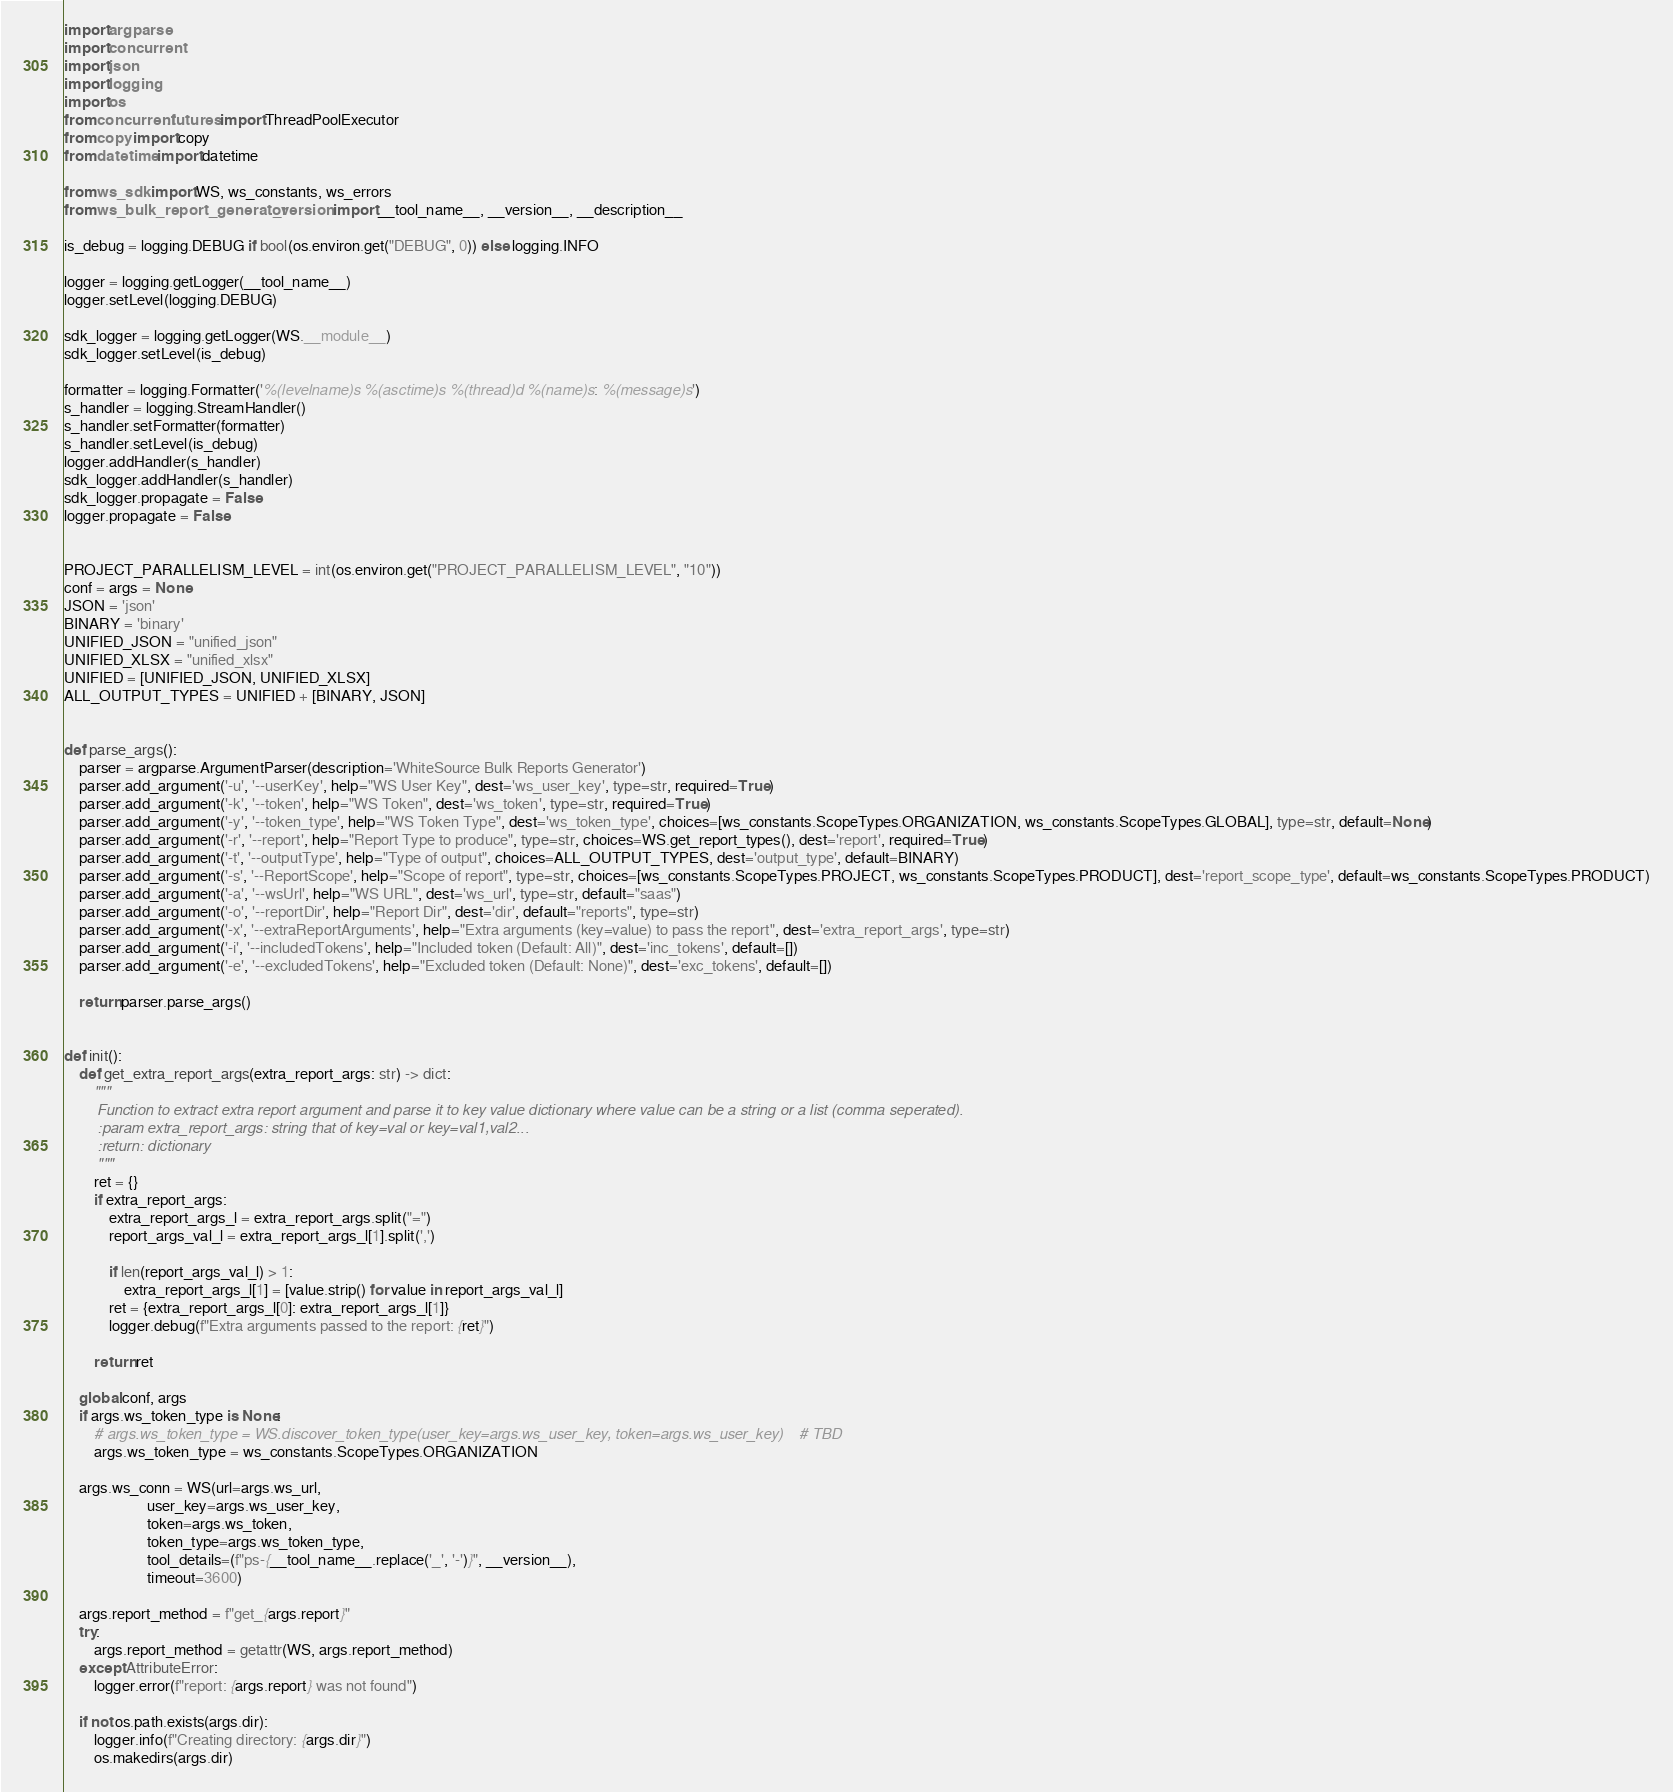Convert code to text. <code><loc_0><loc_0><loc_500><loc_500><_Python_>import argparse
import concurrent
import json
import logging
import os
from concurrent.futures import ThreadPoolExecutor
from copy import copy
from datetime import datetime

from ws_sdk import WS, ws_constants, ws_errors
from ws_bulk_report_generator._version import __tool_name__, __version__, __description__

is_debug = logging.DEBUG if bool(os.environ.get("DEBUG", 0)) else logging.INFO

logger = logging.getLogger(__tool_name__)
logger.setLevel(logging.DEBUG)

sdk_logger = logging.getLogger(WS.__module__)
sdk_logger.setLevel(is_debug)

formatter = logging.Formatter('%(levelname)s %(asctime)s %(thread)d %(name)s: %(message)s')
s_handler = logging.StreamHandler()
s_handler.setFormatter(formatter)
s_handler.setLevel(is_debug)
logger.addHandler(s_handler)
sdk_logger.addHandler(s_handler)
sdk_logger.propagate = False
logger.propagate = False


PROJECT_PARALLELISM_LEVEL = int(os.environ.get("PROJECT_PARALLELISM_LEVEL", "10"))
conf = args = None
JSON = 'json'
BINARY = 'binary'
UNIFIED_JSON = "unified_json"
UNIFIED_XLSX = "unified_xlsx"
UNIFIED = [UNIFIED_JSON, UNIFIED_XLSX]
ALL_OUTPUT_TYPES = UNIFIED + [BINARY, JSON]


def parse_args():
    parser = argparse.ArgumentParser(description='WhiteSource Bulk Reports Generator')
    parser.add_argument('-u', '--userKey', help="WS User Key", dest='ws_user_key', type=str, required=True)
    parser.add_argument('-k', '--token', help="WS Token", dest='ws_token', type=str, required=True)
    parser.add_argument('-y', '--token_type', help="WS Token Type", dest='ws_token_type', choices=[ws_constants.ScopeTypes.ORGANIZATION, ws_constants.ScopeTypes.GLOBAL], type=str, default=None)
    parser.add_argument('-r', '--report', help="Report Type to produce", type=str, choices=WS.get_report_types(), dest='report', required=True)
    parser.add_argument('-t', '--outputType', help="Type of output", choices=ALL_OUTPUT_TYPES, dest='output_type', default=BINARY)
    parser.add_argument('-s', '--ReportScope', help="Scope of report", type=str, choices=[ws_constants.ScopeTypes.PROJECT, ws_constants.ScopeTypes.PRODUCT], dest='report_scope_type', default=ws_constants.ScopeTypes.PRODUCT)
    parser.add_argument('-a', '--wsUrl', help="WS URL", dest='ws_url', type=str, default="saas")
    parser.add_argument('-o', '--reportDir', help="Report Dir", dest='dir', default="reports", type=str)
    parser.add_argument('-x', '--extraReportArguments', help="Extra arguments (key=value) to pass the report", dest='extra_report_args', type=str)
    parser.add_argument('-i', '--includedTokens', help="Included token (Default: All)", dest='inc_tokens', default=[])
    parser.add_argument('-e', '--excludedTokens', help="Excluded token (Default: None)", dest='exc_tokens', default=[])

    return parser.parse_args()


def init():
    def get_extra_report_args(extra_report_args: str) -> dict:
        """
        Function to extract extra report argument and parse it to key value dictionary where value can be a string or a list (comma seperated).
        :param extra_report_args: string that of key=val or key=val1,val2...
        :return: dictionary
        """
        ret = {}
        if extra_report_args:
            extra_report_args_l = extra_report_args.split("=")
            report_args_val_l = extra_report_args_l[1].split(',')

            if len(report_args_val_l) > 1:
                extra_report_args_l[1] = [value.strip() for value in report_args_val_l]
            ret = {extra_report_args_l[0]: extra_report_args_l[1]}
            logger.debug(f"Extra arguments passed to the report: {ret}")

        return ret

    global conf, args
    if args.ws_token_type is None:
        # args.ws_token_type = WS.discover_token_type(user_key=args.ws_user_key, token=args.ws_user_key)    # TBD
        args.ws_token_type = ws_constants.ScopeTypes.ORGANIZATION

    args.ws_conn = WS(url=args.ws_url,
                      user_key=args.ws_user_key,
                      token=args.ws_token,
                      token_type=args.ws_token_type,
                      tool_details=(f"ps-{__tool_name__.replace('_', '-')}", __version__),
                      timeout=3600)

    args.report_method = f"get_{args.report}"
    try:
        args.report_method = getattr(WS, args.report_method)
    except AttributeError:
        logger.error(f"report: {args.report} was not found")

    if not os.path.exists(args.dir):
        logger.info(f"Creating directory: {args.dir}")
        os.makedirs(args.dir)
</code> 